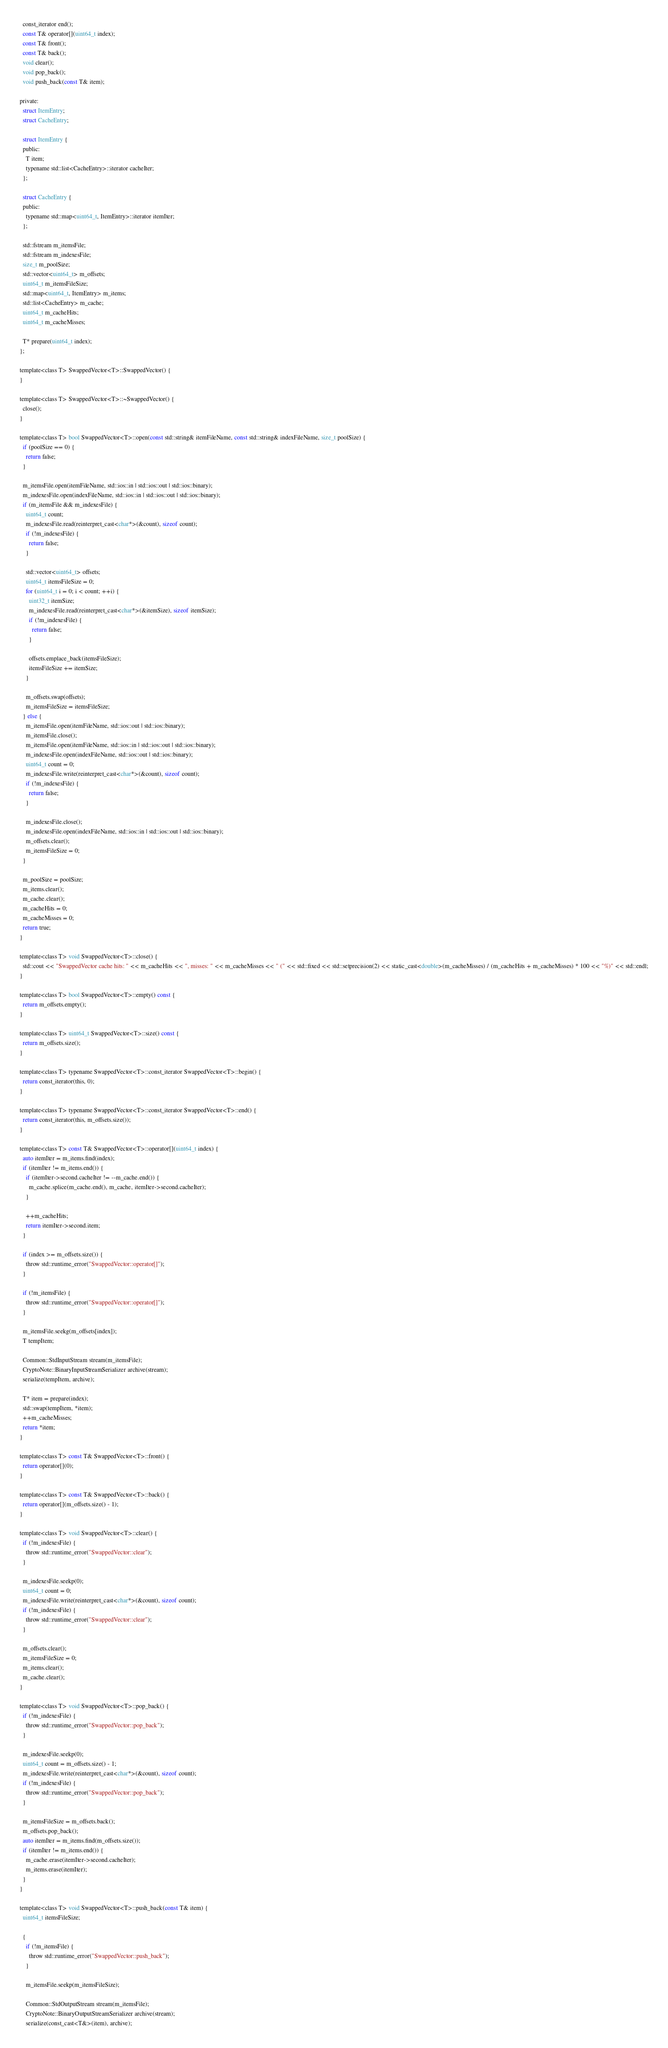Convert code to text. <code><loc_0><loc_0><loc_500><loc_500><_C_>  const_iterator end();
  const T& operator[](uint64_t index);
  const T& front();
  const T& back();
  void clear();
  void pop_back();
  void push_back(const T& item);

private:
  struct ItemEntry;
  struct CacheEntry;

  struct ItemEntry {
  public:
    T item;
    typename std::list<CacheEntry>::iterator cacheIter;
  };

  struct CacheEntry {
  public:
    typename std::map<uint64_t, ItemEntry>::iterator itemIter;
  };

  std::fstream m_itemsFile;
  std::fstream m_indexesFile;
  size_t m_poolSize;
  std::vector<uint64_t> m_offsets;
  uint64_t m_itemsFileSize;
  std::map<uint64_t, ItemEntry> m_items;
  std::list<CacheEntry> m_cache;
  uint64_t m_cacheHits;
  uint64_t m_cacheMisses;

  T* prepare(uint64_t index);
};

template<class T> SwappedVector<T>::SwappedVector() {
}

template<class T> SwappedVector<T>::~SwappedVector() {
  close();
}

template<class T> bool SwappedVector<T>::open(const std::string& itemFileName, const std::string& indexFileName, size_t poolSize) {
  if (poolSize == 0) {
    return false;
  }

  m_itemsFile.open(itemFileName, std::ios::in | std::ios::out | std::ios::binary);
  m_indexesFile.open(indexFileName, std::ios::in | std::ios::out | std::ios::binary);
  if (m_itemsFile && m_indexesFile) {
    uint64_t count;
    m_indexesFile.read(reinterpret_cast<char*>(&count), sizeof count);
    if (!m_indexesFile) {
      return false;
    }

    std::vector<uint64_t> offsets;
    uint64_t itemsFileSize = 0;
    for (uint64_t i = 0; i < count; ++i) {
      uint32_t itemSize;
      m_indexesFile.read(reinterpret_cast<char*>(&itemSize), sizeof itemSize);
      if (!m_indexesFile) {
        return false;
      }

      offsets.emplace_back(itemsFileSize);
      itemsFileSize += itemSize;
    }

    m_offsets.swap(offsets);
    m_itemsFileSize = itemsFileSize;
  } else {
    m_itemsFile.open(itemFileName, std::ios::out | std::ios::binary);
    m_itemsFile.close();
    m_itemsFile.open(itemFileName, std::ios::in | std::ios::out | std::ios::binary);
    m_indexesFile.open(indexFileName, std::ios::out | std::ios::binary);
    uint64_t count = 0;
    m_indexesFile.write(reinterpret_cast<char*>(&count), sizeof count);
    if (!m_indexesFile) {
      return false;
    }

    m_indexesFile.close();
    m_indexesFile.open(indexFileName, std::ios::in | std::ios::out | std::ios::binary);
    m_offsets.clear();
    m_itemsFileSize = 0;
  }

  m_poolSize = poolSize;
  m_items.clear();
  m_cache.clear();
  m_cacheHits = 0;
  m_cacheMisses = 0;
  return true;
}

template<class T> void SwappedVector<T>::close() {
  std::cout << "SwappedVector cache hits: " << m_cacheHits << ", misses: " << m_cacheMisses << " (" << std::fixed << std::setprecision(2) << static_cast<double>(m_cacheMisses) / (m_cacheHits + m_cacheMisses) * 100 << "%)" << std::endl;
}

template<class T> bool SwappedVector<T>::empty() const {
  return m_offsets.empty();
}

template<class T> uint64_t SwappedVector<T>::size() const {
  return m_offsets.size();
}

template<class T> typename SwappedVector<T>::const_iterator SwappedVector<T>::begin() {
  return const_iterator(this, 0);
}

template<class T> typename SwappedVector<T>::const_iterator SwappedVector<T>::end() {
  return const_iterator(this, m_offsets.size());
}

template<class T> const T& SwappedVector<T>::operator[](uint64_t index) {
  auto itemIter = m_items.find(index);
  if (itemIter != m_items.end()) {
    if (itemIter->second.cacheIter != --m_cache.end()) {
      m_cache.splice(m_cache.end(), m_cache, itemIter->second.cacheIter);
    }

    ++m_cacheHits;
    return itemIter->second.item;
  }

  if (index >= m_offsets.size()) {
    throw std::runtime_error("SwappedVector::operator[]");
  }

  if (!m_itemsFile) {
    throw std::runtime_error("SwappedVector::operator[]");
  }

  m_itemsFile.seekg(m_offsets[index]);
  T tempItem;
  
  Common::StdInputStream stream(m_itemsFile);
  CryptoNote::BinaryInputStreamSerializer archive(stream);
  serialize(tempItem, archive);

  T* item = prepare(index);
  std::swap(tempItem, *item);
  ++m_cacheMisses;
  return *item;
}

template<class T> const T& SwappedVector<T>::front() {
  return operator[](0);
}

template<class T> const T& SwappedVector<T>::back() {
  return operator[](m_offsets.size() - 1);
}

template<class T> void SwappedVector<T>::clear() {
  if (!m_indexesFile) {
    throw std::runtime_error("SwappedVector::clear");
  }

  m_indexesFile.seekp(0);
  uint64_t count = 0;
  m_indexesFile.write(reinterpret_cast<char*>(&count), sizeof count);
  if (!m_indexesFile) {
    throw std::runtime_error("SwappedVector::clear");
  }

  m_offsets.clear();
  m_itemsFileSize = 0;
  m_items.clear();
  m_cache.clear();
}

template<class T> void SwappedVector<T>::pop_back() {
  if (!m_indexesFile) {
    throw std::runtime_error("SwappedVector::pop_back");
  }

  m_indexesFile.seekp(0);
  uint64_t count = m_offsets.size() - 1;
  m_indexesFile.write(reinterpret_cast<char*>(&count), sizeof count);
  if (!m_indexesFile) {
    throw std::runtime_error("SwappedVector::pop_back");
  }

  m_itemsFileSize = m_offsets.back();
  m_offsets.pop_back();
  auto itemIter = m_items.find(m_offsets.size());
  if (itemIter != m_items.end()) {
    m_cache.erase(itemIter->second.cacheIter);
    m_items.erase(itemIter);
  }
}

template<class T> void SwappedVector<T>::push_back(const T& item) {
  uint64_t itemsFileSize;

  {
    if (!m_itemsFile) {
      throw std::runtime_error("SwappedVector::push_back");
    }

    m_itemsFile.seekp(m_itemsFileSize);

    Common::StdOutputStream stream(m_itemsFile);
    CryptoNote::BinaryOutputStreamSerializer archive(stream);
    serialize(const_cast<T&>(item), archive);
</code> 